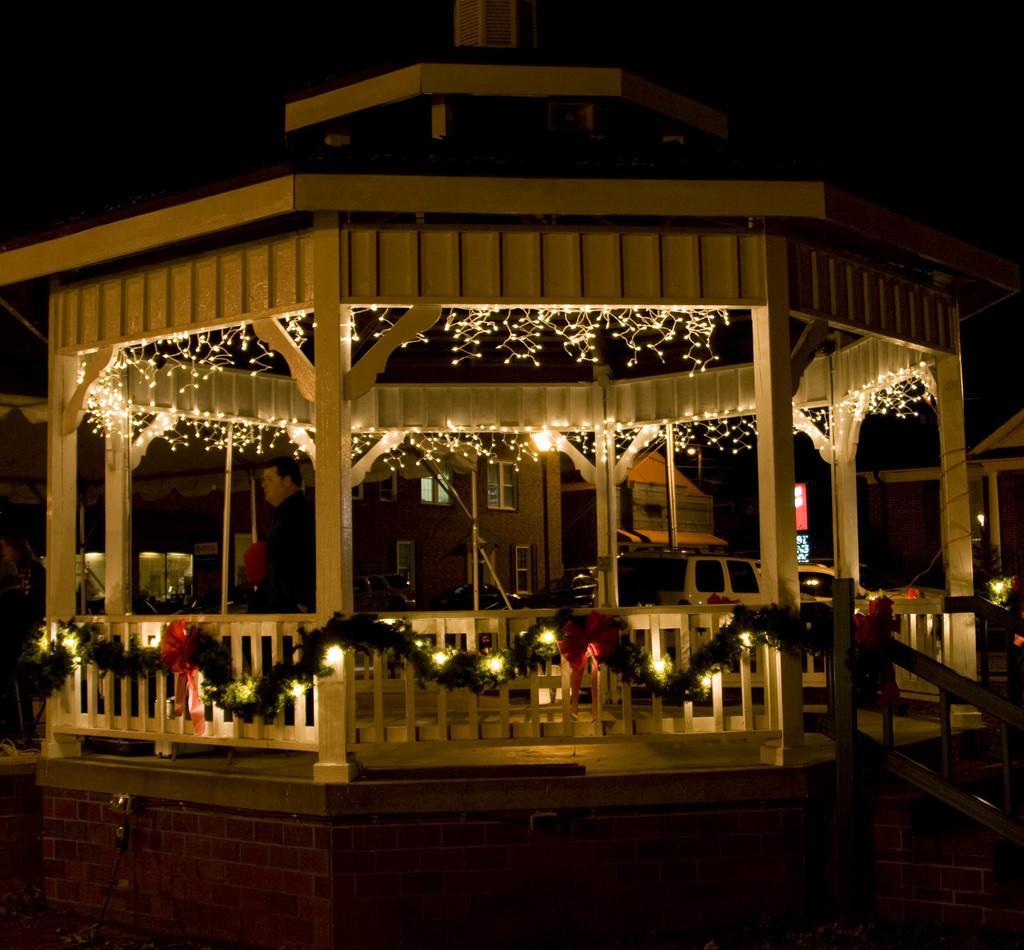Can you describe this image briefly? In this picture I can observe gazebo. There is some lighting in the gazebo. In the background there are houses. 